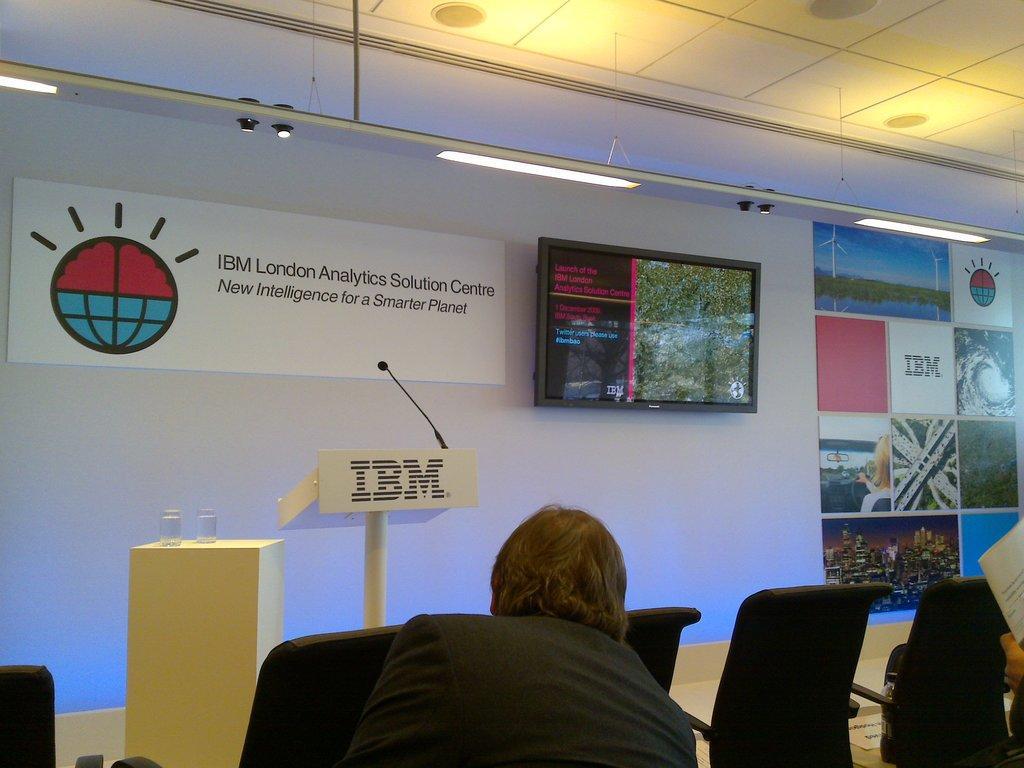How would you summarize this image in a sentence or two? In this image there is a man sitting on chair, in front of the man there are chairs, in the background there is a wall to that wall there are posters, in the top there is a ceiling to that ceiling there are lights. 